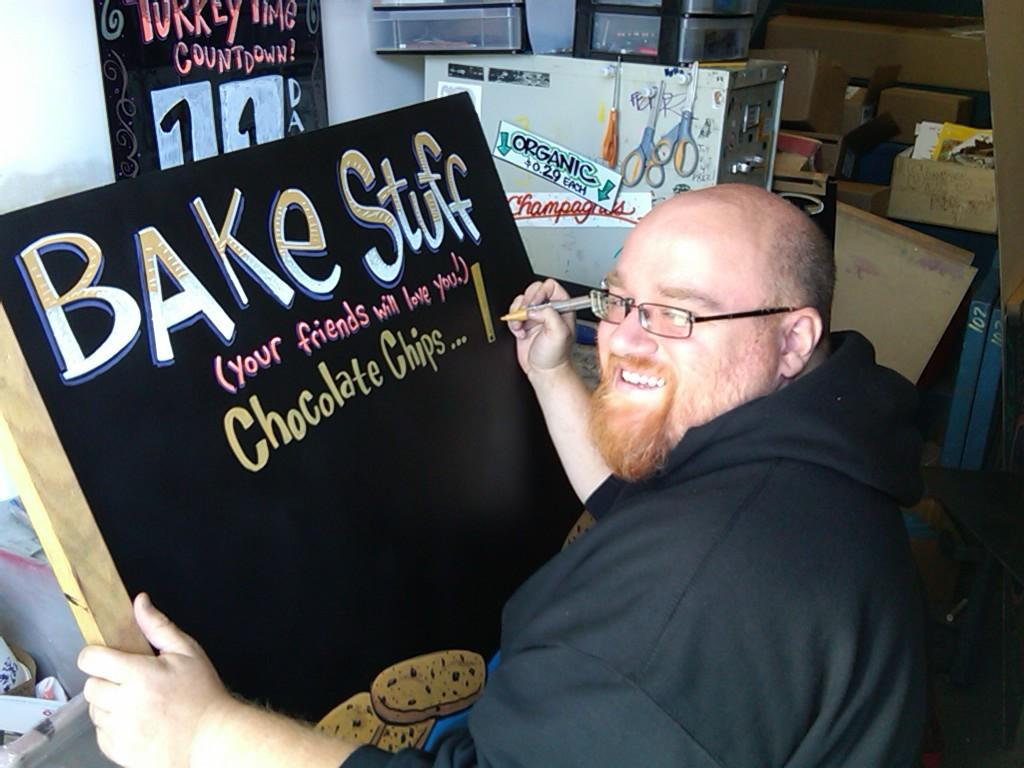<image>
Write a terse but informative summary of the picture. The man is creating a sign for a bake sale with different items. 